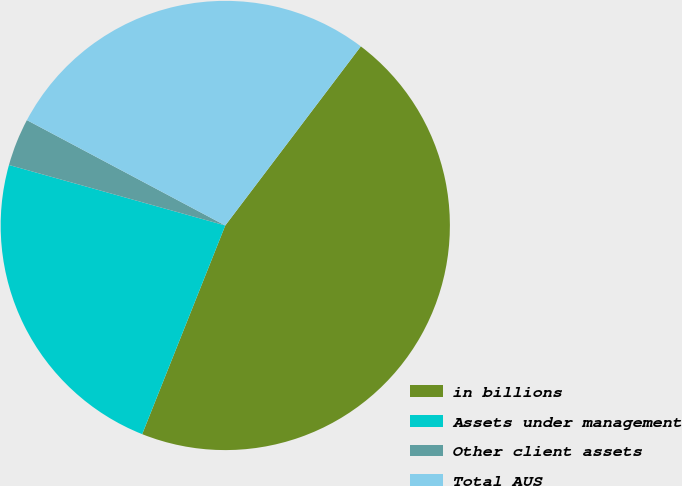<chart> <loc_0><loc_0><loc_500><loc_500><pie_chart><fcel>in billions<fcel>Assets under management<fcel>Other client assets<fcel>Total AUS<nl><fcel>45.72%<fcel>23.31%<fcel>3.43%<fcel>27.54%<nl></chart> 